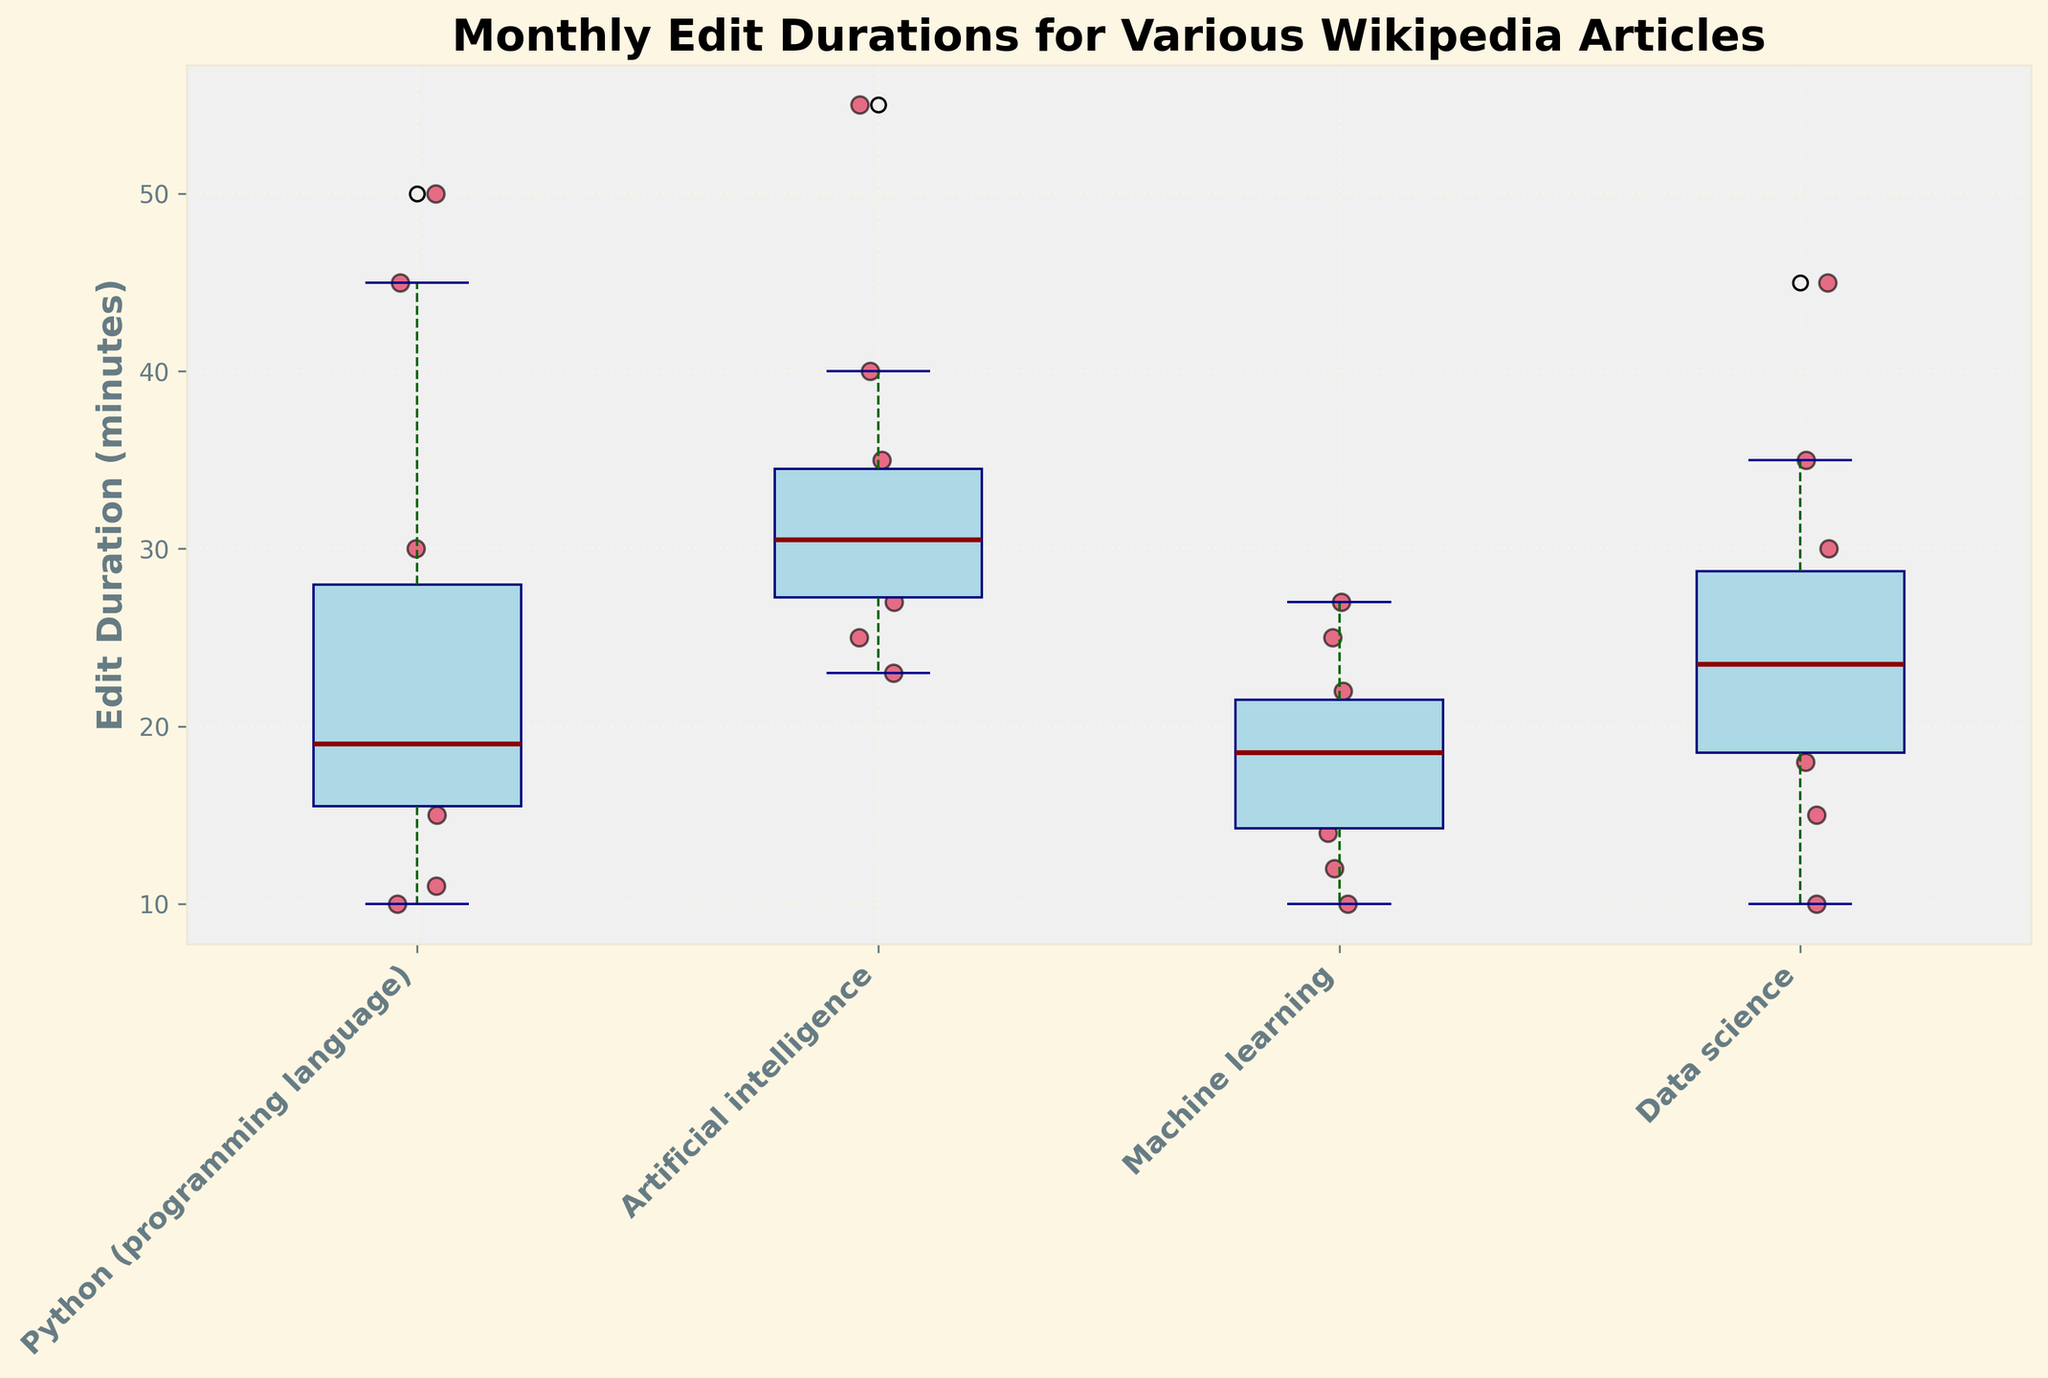What is the title of the plot? The title of the plot is located at the top of the figure, written in a large, bold font.
Answer: Monthly Edit Durations for Various Wikipedia Articles Which article has the longest median edit duration? The box plot displays a horizontal line (the median) within each box. By comparing these lines, the article with the highest median value can be identified.
Answer: Artificial intelligence What is the range of edit durations for the "Python (programming language)" article? The range in a box plot is indicated by the distance between the lowest whisker and the highest whisker. For "Python (programming language)", identify these extremes.
Answer: 10 to 50 minutes How many articles have outliers based on the box plot? Outliers in a box plot are typically shown as individual points beyond the whiskers. Count the articles that have these points.
Answer: 2 Which article has the smallest interquartile range (IQR)? The IQR is the length of the box itself. By comparing the widths of the boxes, the article with the smallest box can be identified.
Answer: Machine learning What's the median edit duration for the "Data science" article? In the box plot, the median is shown by the central line within the box for each article. Locate the "Data science" article and find its median line.
Answer: 22.5 minutes How does the whisker length of "Data science" compare to "Artificial intelligence"? Compare the lengths of whiskers for both articles. "Data science" seems to have longer whiskers than "Artificial intelligence" indicating a larger range.
Answer: Data science whiskers are longer Which article shows the highest variability in edit duration? The highest variability can be inferred by the size of the box and the length of the whiskers. The largest range from whisker to whisker will indicate the most variability.
Answer: Artificial intelligence Are there any visible patterns or trends in the distribution of edit durations across the articles? Look for any visible trends such as more clusters, higher medians, presence of outliers, or wider ranges across the box plots.
Answer: Edit durations seem to vary significantly with some articles like "Artificial intelligence" showing a higher median and wider range compared to others like "Machine learning" 